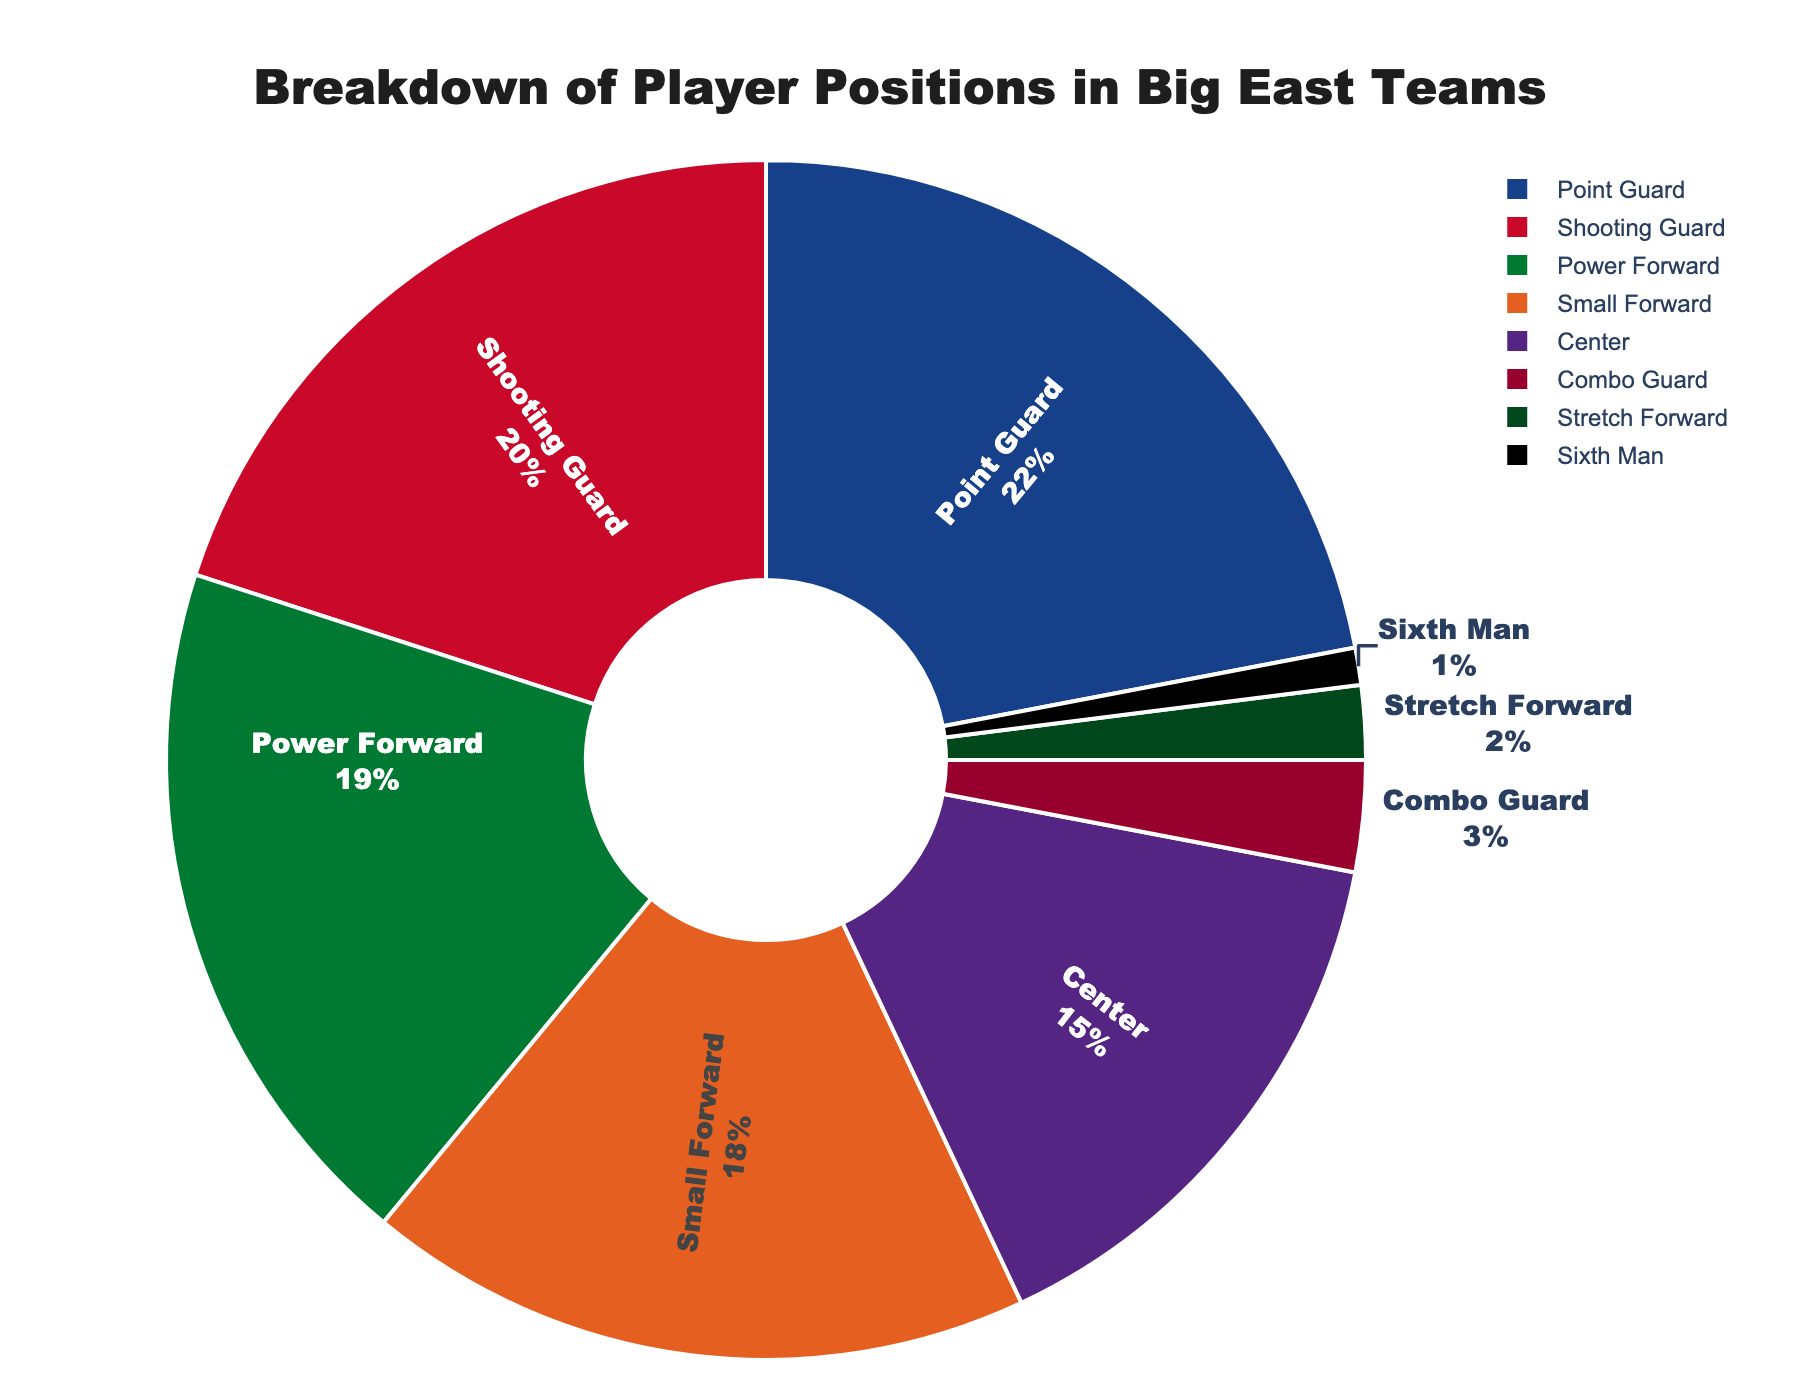What percentage of players were Point Guards? The pie chart shows that Point Guards made up 22% of the players.
Answer: 22% How do the percentages of Shooting Guards and Power Forwards compare? The pie chart indicates that Shooting Guards made up 20% and Power Forwards accounted for 19% of the players. By comparing these two values, Shooting Guards have a slightly higher percentage than Power Forwards.
Answer: Shooting Guards have 1% more than Power Forwards Which position has the smallest representation, and what is its percentage? The pie chart shows that the Sixth Man position has the smallest representation, making up 1% of the players.
Answer: Sixth Man, 1% What is the combined percentage of Small Forwards and Centers? The pie chart shows that Small Forwards make up 18% and Centers make up 15%. Added together, 18% + 15% = 33%.
Answer: 33% Is the percentage of Point Guards greater or less than the combined percentage of Combo Guards and Stretch Forwards? The pie chart indicates Point Guards are 22%, Combo Guards are 3%, and Stretch Forwards are 2%. The combined percentage of Combo Guards and Stretch Forwards is 3% + 2% = 5%, which is less than the 22% of Point Guards.
Answer: Point Guards are greater Which three positions collectively make up more than half of the chart? Point Guards, Shooting Guards, and Small Forwards each contribute 22%, 20%, and 18%, respectively. Collectively, 22% + 20% + 18% = 60%, which is more than 50%.
Answer: Point Guards, Shooting Guards, Small Forwards If you combined the percentage of Centers and Stretch Forwards, would their total be more or less than Power Forwards? Centers are 15%, and Stretch Forwards are 2%. Combined, they make 17%. Power Forwards account for 19%. Therefore, 17% is less than 19%.
Answer: Less What's the difference in percentage between the most and least represented positions? The pie chart shows the most represented position is Point Guard at 22% and the least is the Sixth Man at 1%. The difference is 22% - 1% = 21%.
Answer: 21% How many positions have a representation of 10% or more? From the pie chart, the positions with a representation of 10% or more are Point Guard (22%), Shooting Guard (20%), Small Forward (18%), Power Forward (19%), and Center (15%). This makes a total of 5 positions.
Answer: 5 Which position is represented by the green color, and what is its percentage? The pie chart indicates that the green color represents the Power Forward position, which makes up 19% of the players.
Answer: Power Forward, 19% 